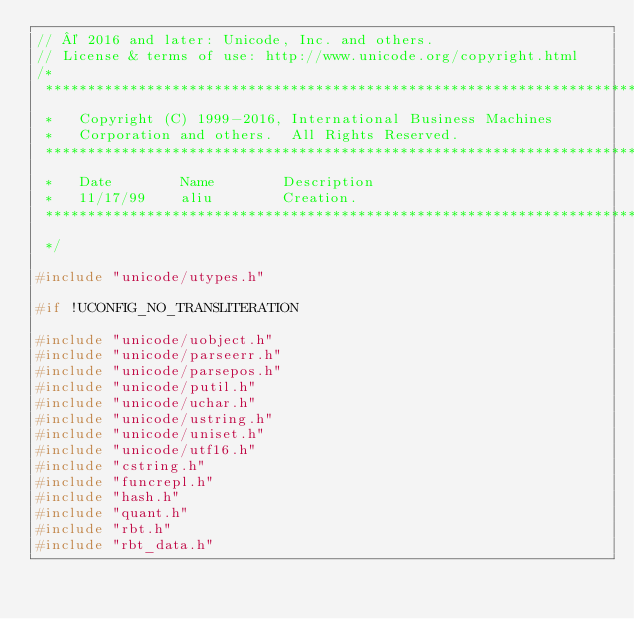<code> <loc_0><loc_0><loc_500><loc_500><_C++_>// © 2016 and later: Unicode, Inc. and others.
// License & terms of use: http://www.unicode.org/copyright.html
/*
 **********************************************************************
 *   Copyright (C) 1999-2016, International Business Machines
 *   Corporation and others.  All Rights Reserved.
 **********************************************************************
 *   Date        Name        Description
 *   11/17/99    aliu        Creation.
 **********************************************************************
 */

#include "unicode/utypes.h"

#if !UCONFIG_NO_TRANSLITERATION

#include "unicode/uobject.h"
#include "unicode/parseerr.h"
#include "unicode/parsepos.h"
#include "unicode/putil.h"
#include "unicode/uchar.h"
#include "unicode/ustring.h"
#include "unicode/uniset.h"
#include "unicode/utf16.h"
#include "cstring.h"
#include "funcrepl.h"
#include "hash.h"
#include "quant.h"
#include "rbt.h"
#include "rbt_data.h"</code> 